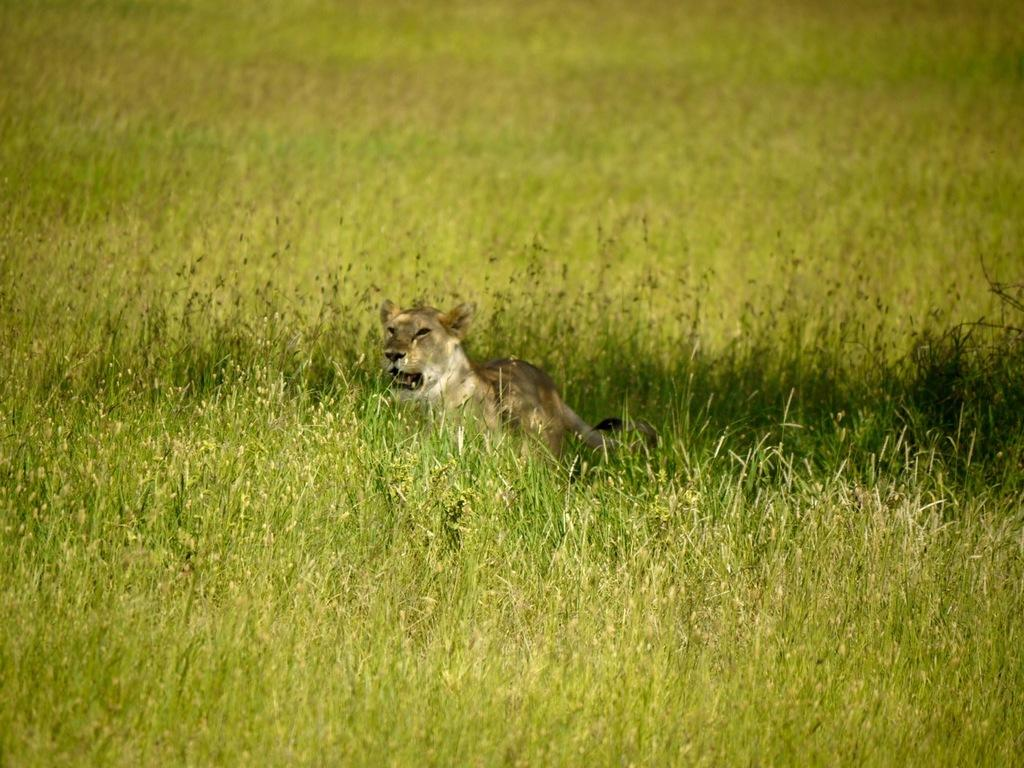What type of living creature is in the image? There is an animal in the image. What is the color and texture of the ground in the image? There is green grass in the image. How does the animal provide comfort to the hand in the image? There is no hand present in the image, and the animal is not shown providing comfort to anyone or anything. 